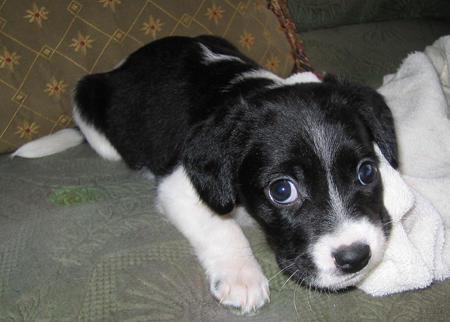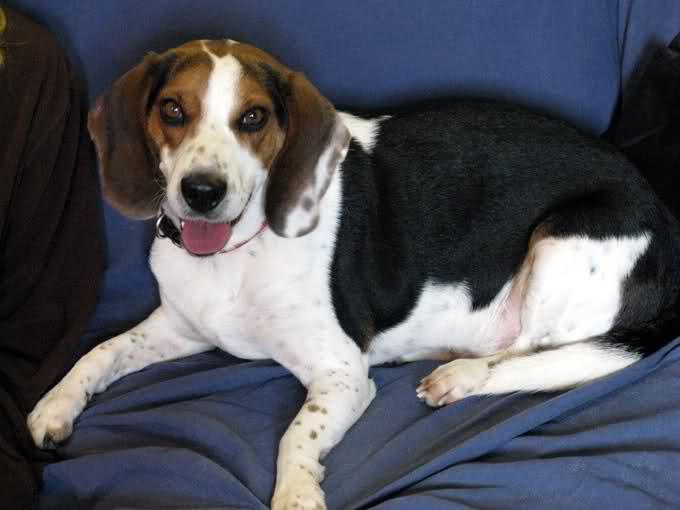The first image is the image on the left, the second image is the image on the right. Analyze the images presented: Is the assertion "One dog in the image on the left is standing up on all fours." valid? Answer yes or no. No. The first image is the image on the left, the second image is the image on the right. Considering the images on both sides, is "An image includes a standing dog with its tail upright and curved inward." valid? Answer yes or no. No. 